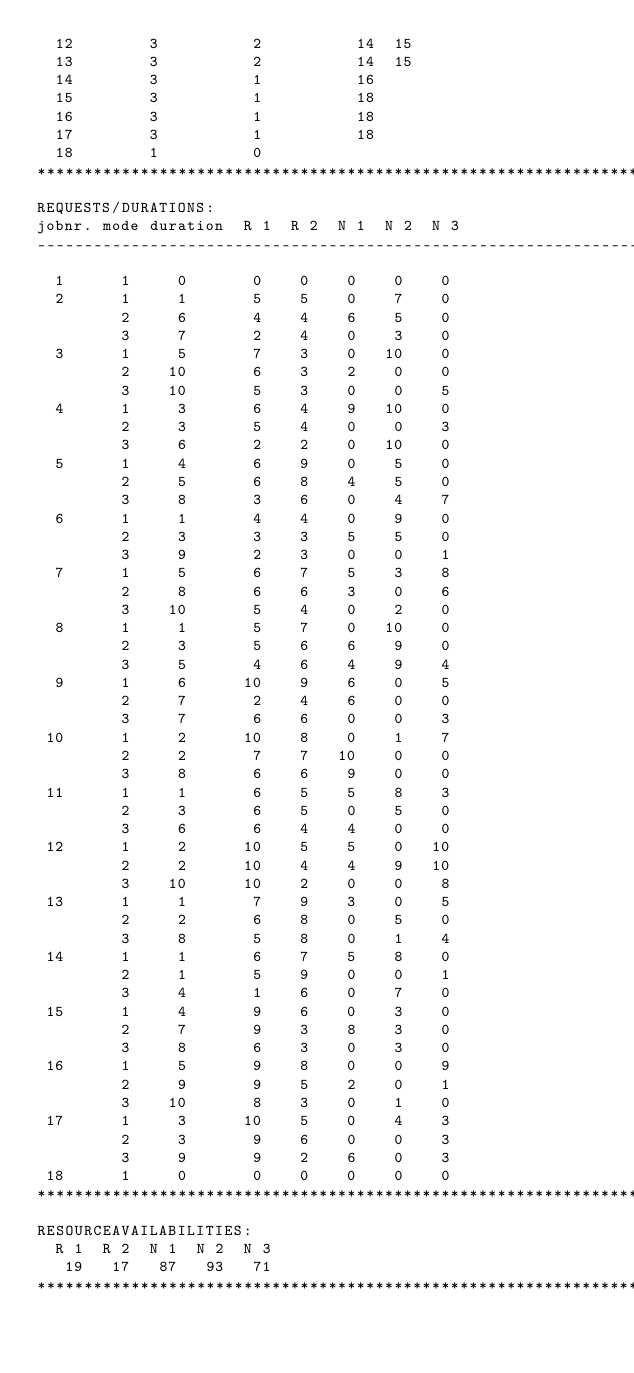<code> <loc_0><loc_0><loc_500><loc_500><_ObjectiveC_>  12        3          2          14  15
  13        3          2          14  15
  14        3          1          16
  15        3          1          18
  16        3          1          18
  17        3          1          18
  18        1          0        
************************************************************************
REQUESTS/DURATIONS:
jobnr. mode duration  R 1  R 2  N 1  N 2  N 3
------------------------------------------------------------------------
  1      1     0       0    0    0    0    0
  2      1     1       5    5    0    7    0
         2     6       4    4    6    5    0
         3     7       2    4    0    3    0
  3      1     5       7    3    0   10    0
         2    10       6    3    2    0    0
         3    10       5    3    0    0    5
  4      1     3       6    4    9   10    0
         2     3       5    4    0    0    3
         3     6       2    2    0   10    0
  5      1     4       6    9    0    5    0
         2     5       6    8    4    5    0
         3     8       3    6    0    4    7
  6      1     1       4    4    0    9    0
         2     3       3    3    5    5    0
         3     9       2    3    0    0    1
  7      1     5       6    7    5    3    8
         2     8       6    6    3    0    6
         3    10       5    4    0    2    0
  8      1     1       5    7    0   10    0
         2     3       5    6    6    9    0
         3     5       4    6    4    9    4
  9      1     6      10    9    6    0    5
         2     7       2    4    6    0    0
         3     7       6    6    0    0    3
 10      1     2      10    8    0    1    7
         2     2       7    7   10    0    0
         3     8       6    6    9    0    0
 11      1     1       6    5    5    8    3
         2     3       6    5    0    5    0
         3     6       6    4    4    0    0
 12      1     2      10    5    5    0   10
         2     2      10    4    4    9   10
         3    10      10    2    0    0    8
 13      1     1       7    9    3    0    5
         2     2       6    8    0    5    0
         3     8       5    8    0    1    4
 14      1     1       6    7    5    8    0
         2     1       5    9    0    0    1
         3     4       1    6    0    7    0
 15      1     4       9    6    0    3    0
         2     7       9    3    8    3    0
         3     8       6    3    0    3    0
 16      1     5       9    8    0    0    9
         2     9       9    5    2    0    1
         3    10       8    3    0    1    0
 17      1     3      10    5    0    4    3
         2     3       9    6    0    0    3
         3     9       9    2    6    0    3
 18      1     0       0    0    0    0    0
************************************************************************
RESOURCEAVAILABILITIES:
  R 1  R 2  N 1  N 2  N 3
   19   17   87   93   71
************************************************************************
</code> 